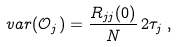<formula> <loc_0><loc_0><loc_500><loc_500>v a r ( \mathcal { O } _ { j } ) = \frac { R _ { j j } ( 0 ) } { N } \, 2 \tau _ { j } \, ,</formula> 